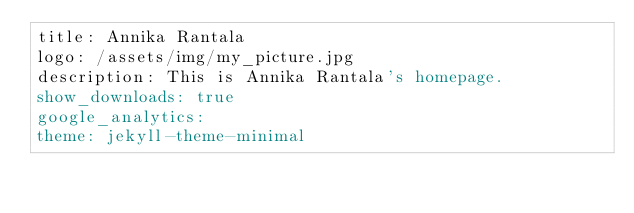Convert code to text. <code><loc_0><loc_0><loc_500><loc_500><_YAML_>title: Annika Rantala
logo: /assets/img/my_picture.jpg
description: This is Annika Rantala's homepage.
show_downloads: true
google_analytics:
theme: jekyll-theme-minimal
</code> 